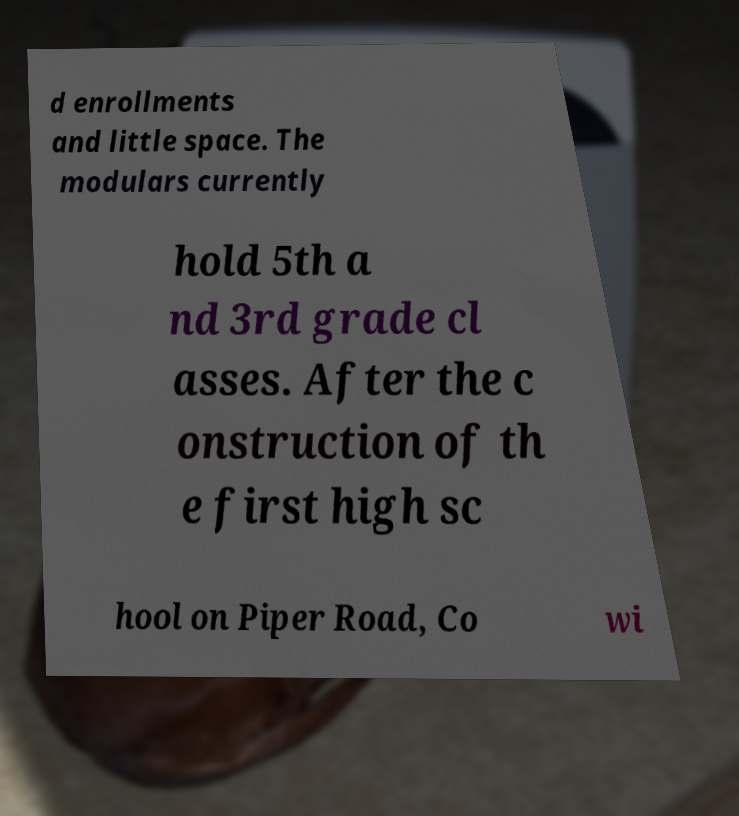Could you assist in decoding the text presented in this image and type it out clearly? d enrollments and little space. The modulars currently hold 5th a nd 3rd grade cl asses. After the c onstruction of th e first high sc hool on Piper Road, Co wi 